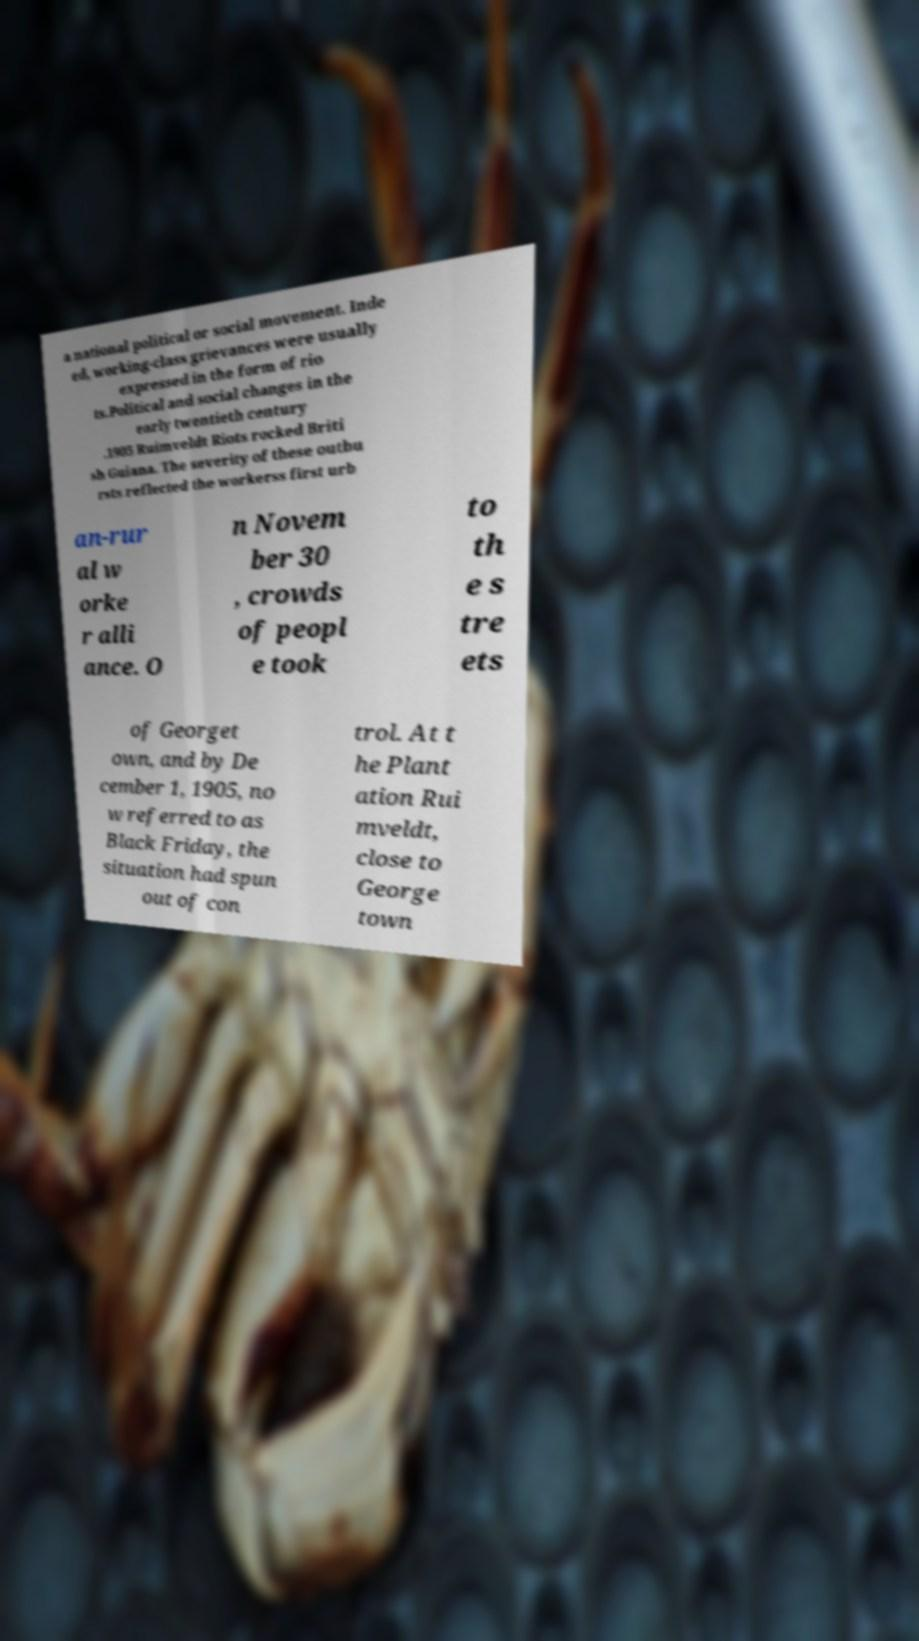For documentation purposes, I need the text within this image transcribed. Could you provide that? a national political or social movement. Inde ed, working-class grievances were usually expressed in the form of rio ts.Political and social changes in the early twentieth century .1905 Ruimveldt Riots rocked Briti sh Guiana. The severity of these outbu rsts reflected the workerss first urb an-rur al w orke r alli ance. O n Novem ber 30 , crowds of peopl e took to th e s tre ets of Georget own, and by De cember 1, 1905, no w referred to as Black Friday, the situation had spun out of con trol. At t he Plant ation Rui mveldt, close to George town 